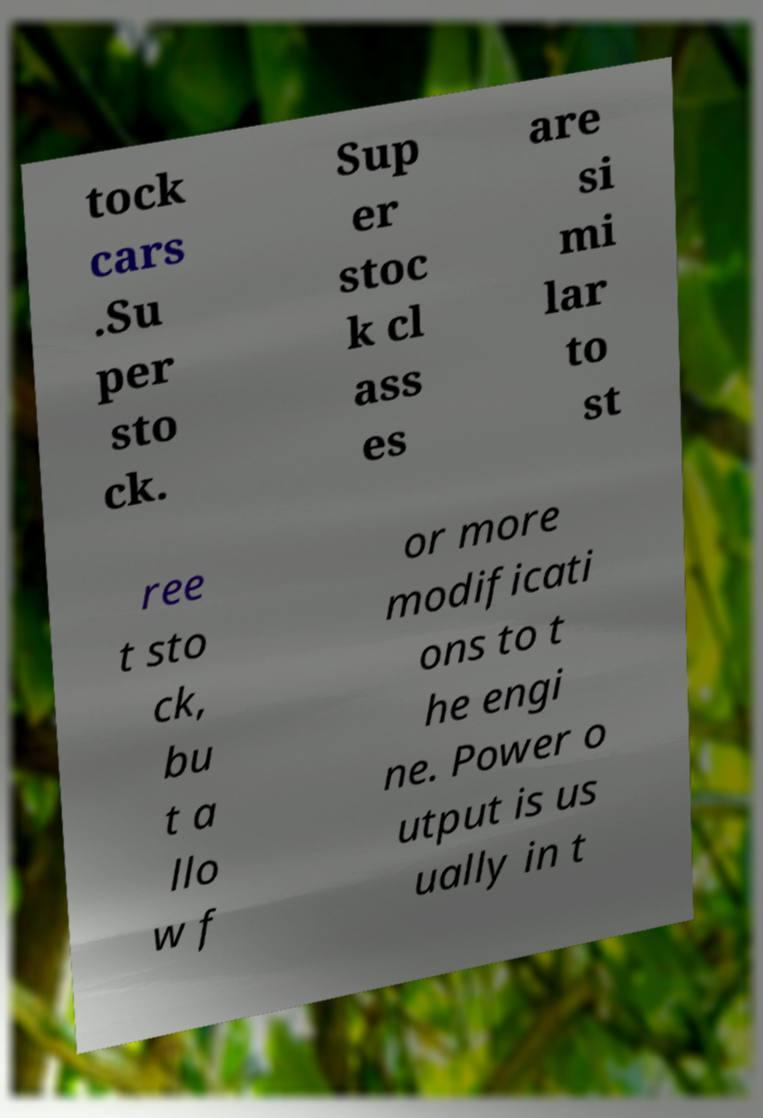What messages or text are displayed in this image? I need them in a readable, typed format. tock cars .Su per sto ck. Sup er stoc k cl ass es are si mi lar to st ree t sto ck, bu t a llo w f or more modificati ons to t he engi ne. Power o utput is us ually in t 